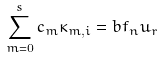Convert formula to latex. <formula><loc_0><loc_0><loc_500><loc_500>\sum _ { m = 0 } ^ { s } c _ { m } \kappa _ { m , i } = b f _ { n } u _ { r }</formula> 